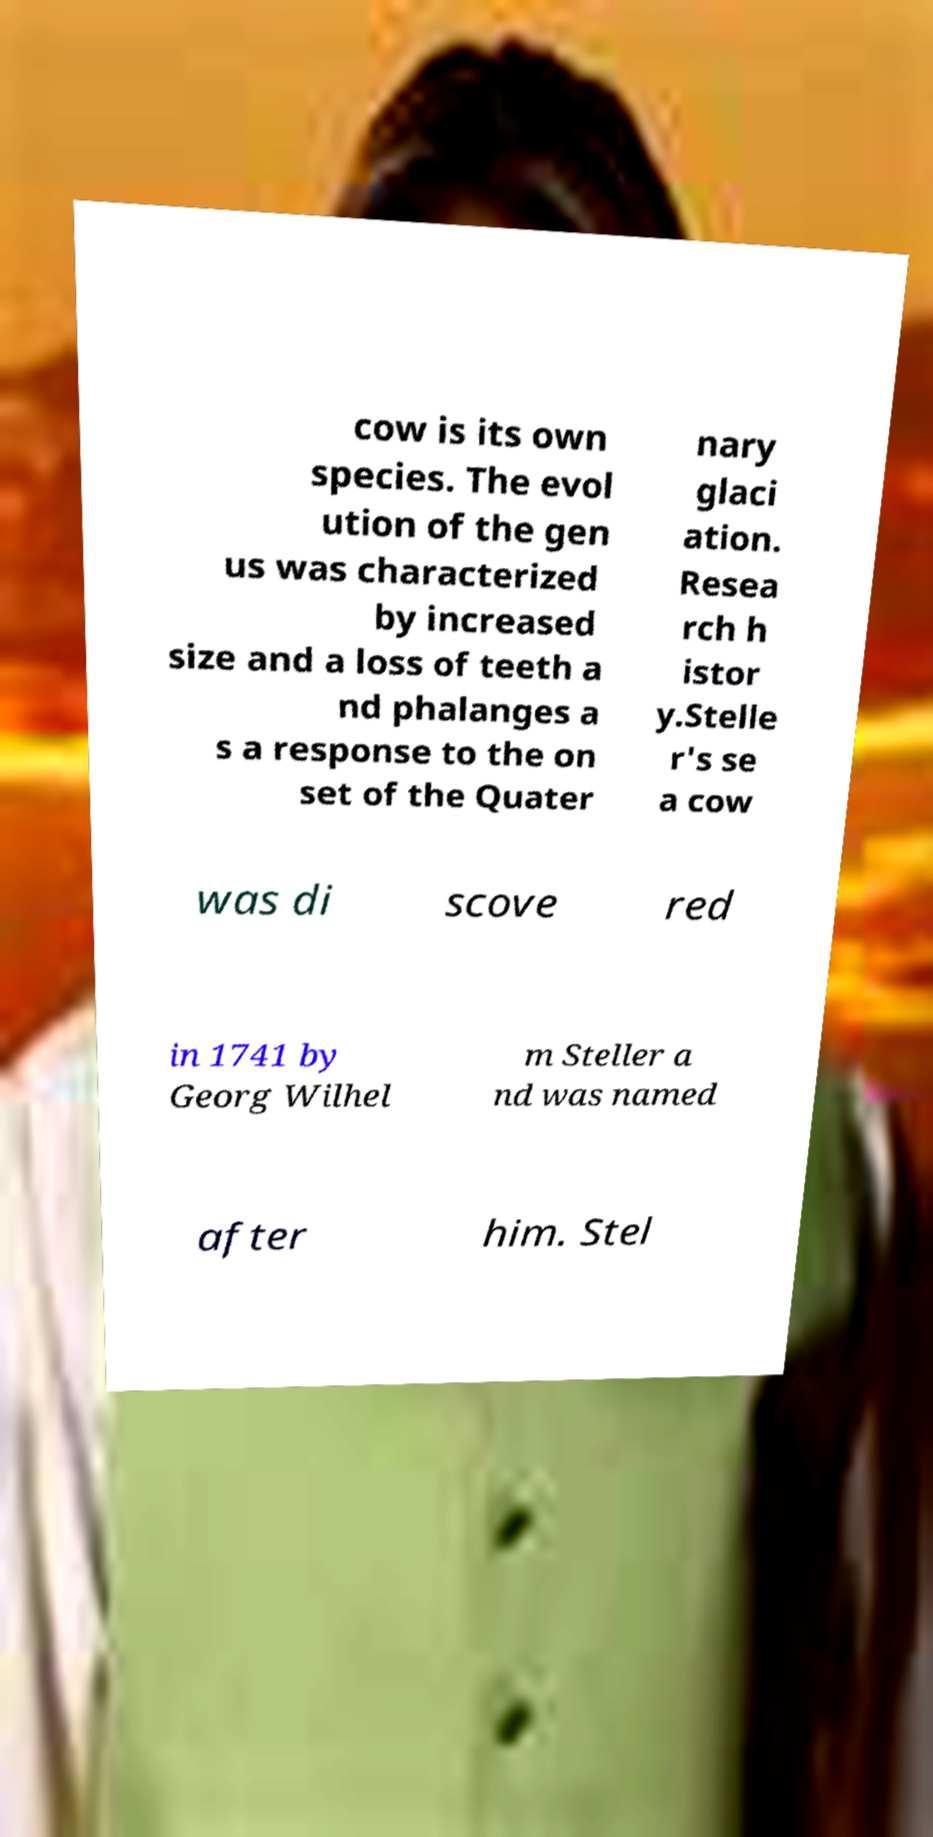What messages or text are displayed in this image? I need them in a readable, typed format. cow is its own species. The evol ution of the gen us was characterized by increased size and a loss of teeth a nd phalanges a s a response to the on set of the Quater nary glaci ation. Resea rch h istor y.Stelle r's se a cow was di scove red in 1741 by Georg Wilhel m Steller a nd was named after him. Stel 